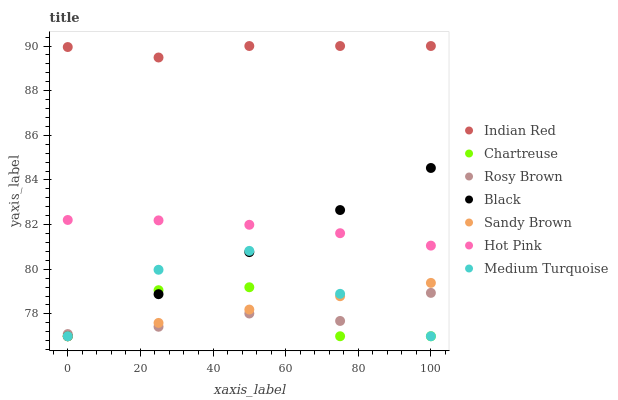Does Rosy Brown have the minimum area under the curve?
Answer yes or no. Yes. Does Indian Red have the maximum area under the curve?
Answer yes or no. Yes. Does Medium Turquoise have the minimum area under the curve?
Answer yes or no. No. Does Medium Turquoise have the maximum area under the curve?
Answer yes or no. No. Is Sandy Brown the smoothest?
Answer yes or no. Yes. Is Chartreuse the roughest?
Answer yes or no. Yes. Is Medium Turquoise the smoothest?
Answer yes or no. No. Is Medium Turquoise the roughest?
Answer yes or no. No. Does Medium Turquoise have the lowest value?
Answer yes or no. Yes. Does Rosy Brown have the lowest value?
Answer yes or no. No. Does Indian Red have the highest value?
Answer yes or no. Yes. Does Medium Turquoise have the highest value?
Answer yes or no. No. Is Rosy Brown less than Indian Red?
Answer yes or no. Yes. Is Hot Pink greater than Sandy Brown?
Answer yes or no. Yes. Does Chartreuse intersect Rosy Brown?
Answer yes or no. Yes. Is Chartreuse less than Rosy Brown?
Answer yes or no. No. Is Chartreuse greater than Rosy Brown?
Answer yes or no. No. Does Rosy Brown intersect Indian Red?
Answer yes or no. No. 